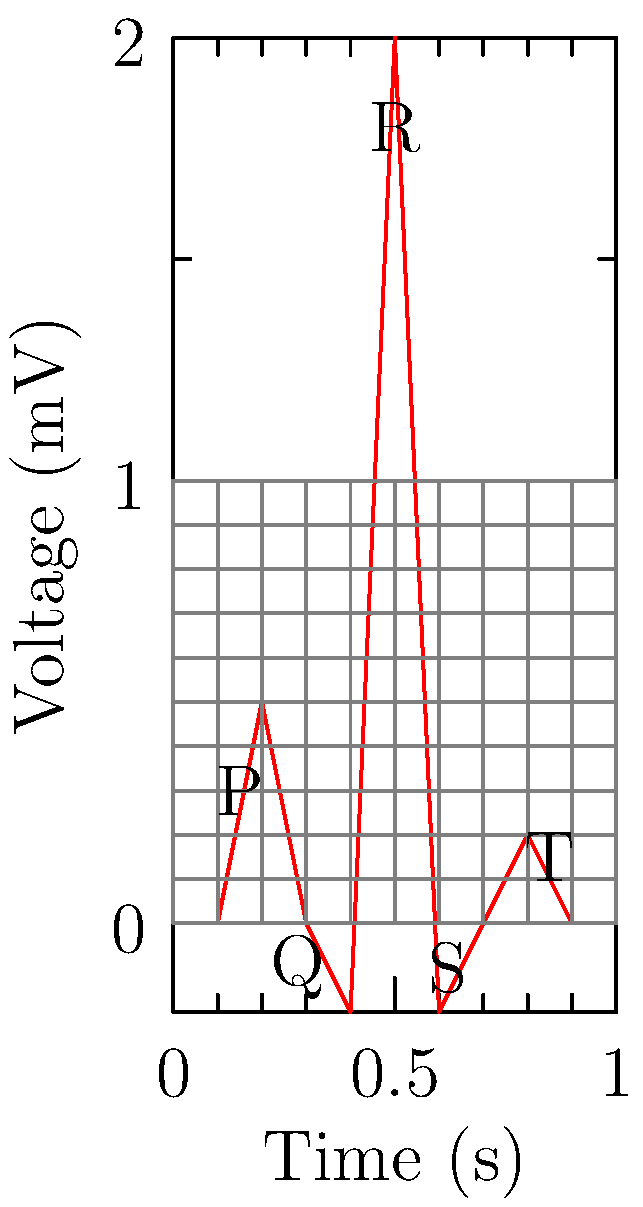Analyze the provided ECG and determine the QT interval. What does an abnormally prolonged QT interval indicate, and why is this knowledge crucial for nursing education? To answer this question, let's break it down step-by-step:

1. Identifying the QT interval:
   - The QT interval is measured from the beginning of the Q wave to the end of the T wave.
   - In the given ECG, the Q wave starts at approximately 0.28 seconds, and the T wave ends at about 0.9 seconds.
   - Therefore, the QT interval is approximately 0.62 seconds (0.9 - 0.28 = 0.62).

2. Normal QT interval:
   - The normal QT interval is typically less than 0.44 seconds for men and 0.46 seconds for women.
   - The exact normal range can vary based on heart rate and should be corrected using formulas like Bazett's.

3. Significance of a prolonged QT interval:
   - An abnormally prolonged QT interval indicates delayed ventricular repolarization.
   - This can lead to a potentially life-threatening arrhythmia called Torsades de Pointes.

4. Causes of prolonged QT interval:
   - Congenital long QT syndrome
   - Electrolyte imbalances (e.g., hypokalemia, hypomagnesemia)
   - Certain medications (e.g., some antiarrhythmics, antipsychotics, antibiotics)
   - Structural heart disease
   - Bradycardia

5. Importance in nursing education:
   - Patient safety: Nurses need to recognize prolonged QT intervals to prevent potentially fatal arrhythmias.
   - Medication management: Understanding QT prolongation helps in monitoring patients on QT-prolonging drugs.
   - Risk assessment: Identifying patients at risk for long QT syndrome is crucial for appropriate care planning.
   - Interprofessional communication: Nurses must effectively communicate ECG findings to the healthcare team.
   - Patient education: Nurses play a key role in educating patients about their condition and necessary precautions.

Understanding QT interval interpretation is essential for developing a comprehensive nursing curriculum that prepares future nurses for critical patient care situations.
Answer: Prolonged ventricular repolarization, risking Torsades de Pointes; crucial for patient safety, medication management, and effective healthcare team communication. 